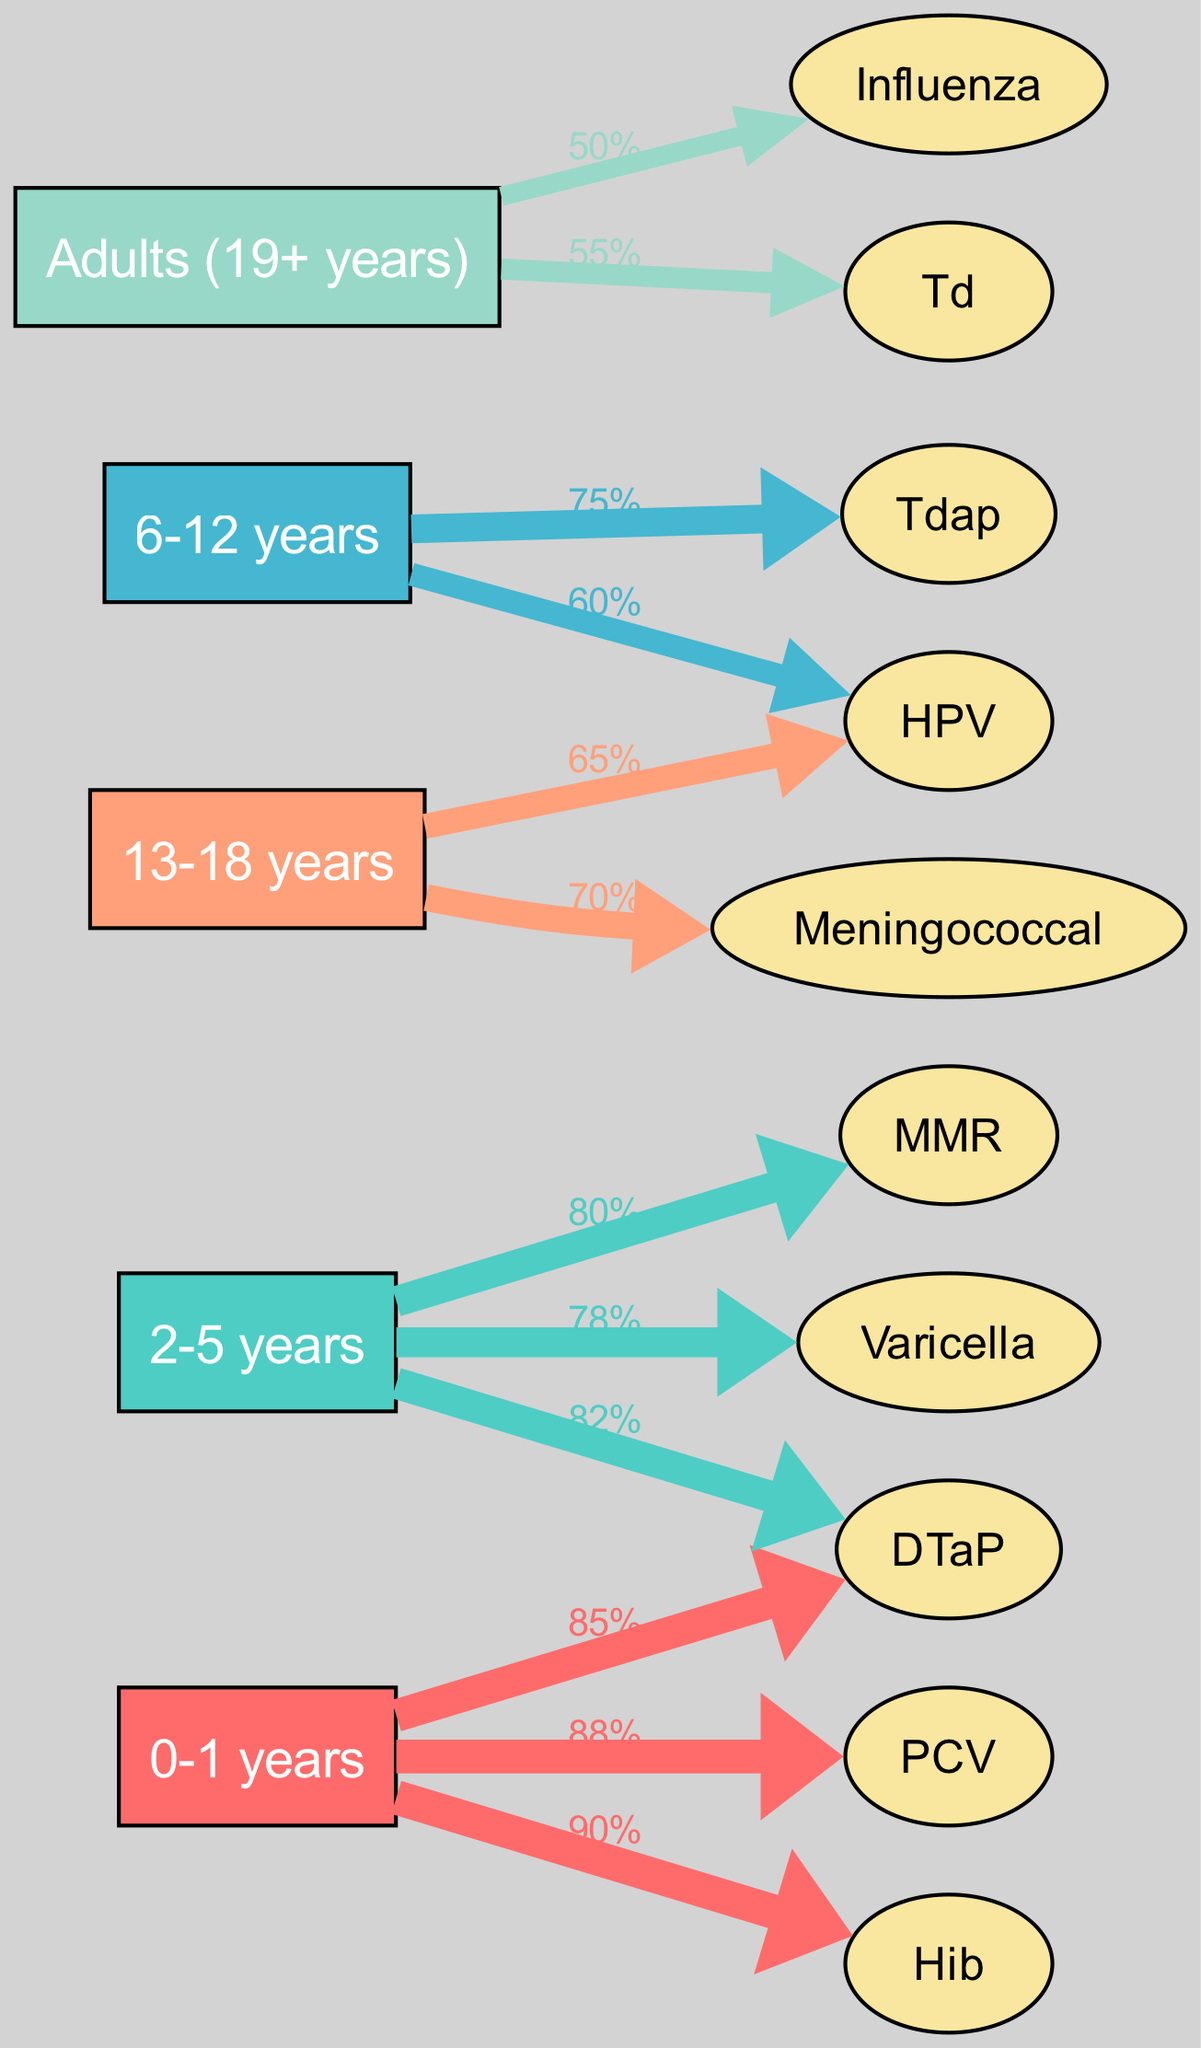What is the vaccination rate for DTaP in the 0-1 years age group? According to the diagram, the DTaP vaccination rate for the 0-1 years age group is directly labeled as 85%.
Answer: 85% Which vaccine has the highest vaccination rate in the 2-5 years age group? The diagram shows three vaccines in the 2-5 years age group: MMR (80%), Varicella (78%), and DTaP (82%). Among these, DTaP has the highest rate of 82%.
Answer: DTaP How many vaccines are administered to the 13-18 years age group? The 13-18 years age group shows two vaccines: HPV and Meningococcal. Counting these gives us a total of two vaccines.
Answer: 2 What is the average vaccination rate of all vaccines in the Adults (19+ years) age group? The Adult group vaccinations are Influenza (50%) and Td (55%). To find the average: (50% + 55%) / 2 = 52.5%. Thus the average is 52.5%.
Answer: 52.5% Which age group has the lowest overall vaccination rate? Examining the age groups, the 6-12 years group has Tdap (75%) and HPV (60%). The lower of these two rates, 60% for HPV, combined with a higher average in the next age group shows that the 6-12 years group has the overall lowest vaccination rates.
Answer: 6-12 years What is the vaccination rate for HPV in the 6-12 years age group? The diagram indicates that the HPV vaccination rate in the 6-12 years age group is labeled as 60%.
Answer: 60% How many total edges are there for the age group 0-1 years? For the 0-1 years age group, there are three vaccines: DTaP, Hib, and PCV, each connected to the age group node which gives us a total of three edges.
Answer: 3 What is the specific vaccination rate for the Varicella vaccine? Looking at the overall vaccines, Varicella has a specific vaccination rate marked as 78% in the 2-5 years age group.
Answer: 78% Which age group has a higher vaccination rate for HPV, 6-12 years or 13-18 years? The HPV rate for 6-12 years is 60%, while for 13-18 years it is 65%. Since 65% is greater than 60%, the 13-18 years age group has the higher rate.
Answer: 13-18 years 